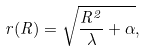Convert formula to latex. <formula><loc_0><loc_0><loc_500><loc_500>r ( R ) = \sqrt { \frac { R ^ { 2 } } { \lambda } + \alpha } ,</formula> 